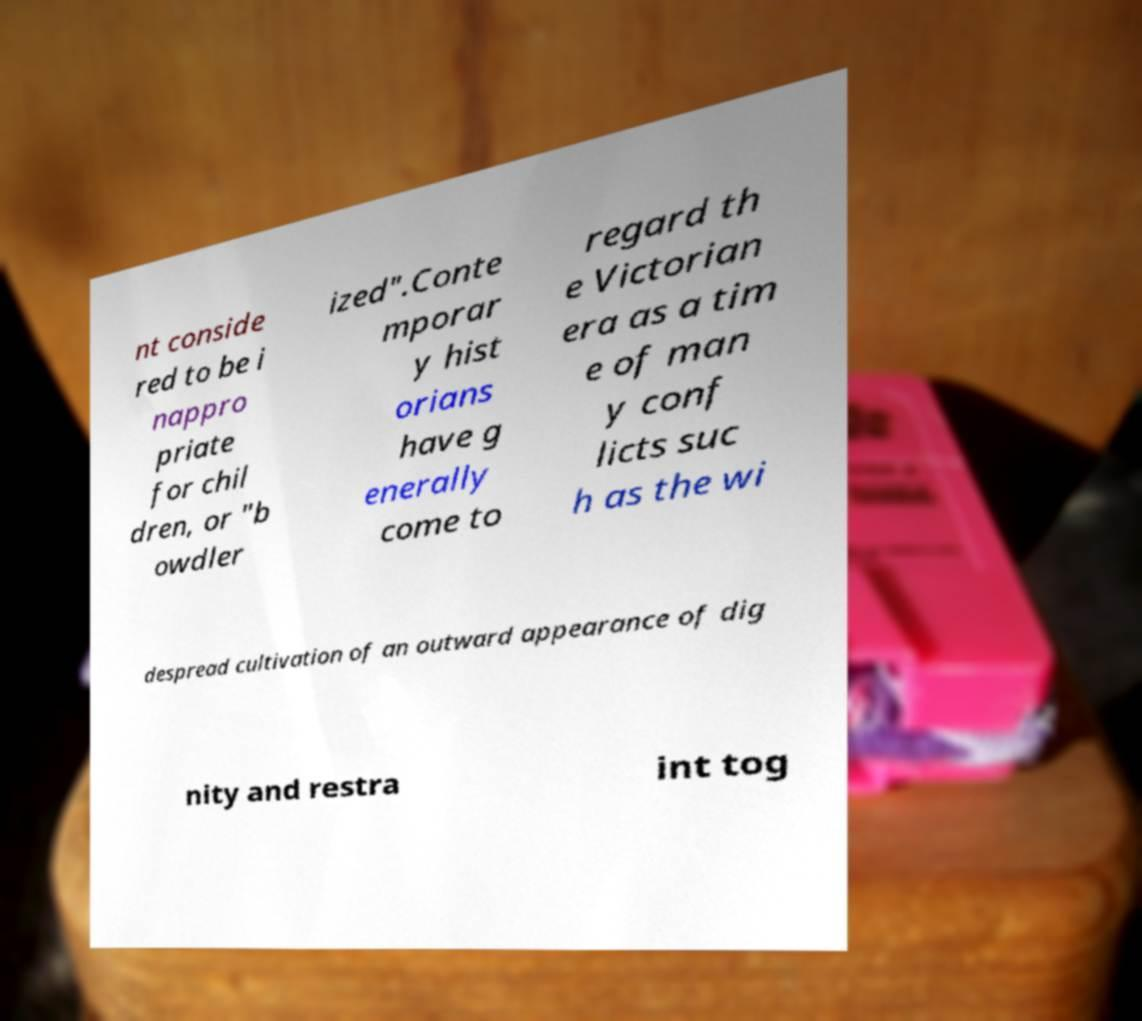Could you extract and type out the text from this image? nt conside red to be i nappro priate for chil dren, or "b owdler ized".Conte mporar y hist orians have g enerally come to regard th e Victorian era as a tim e of man y conf licts suc h as the wi despread cultivation of an outward appearance of dig nity and restra int tog 